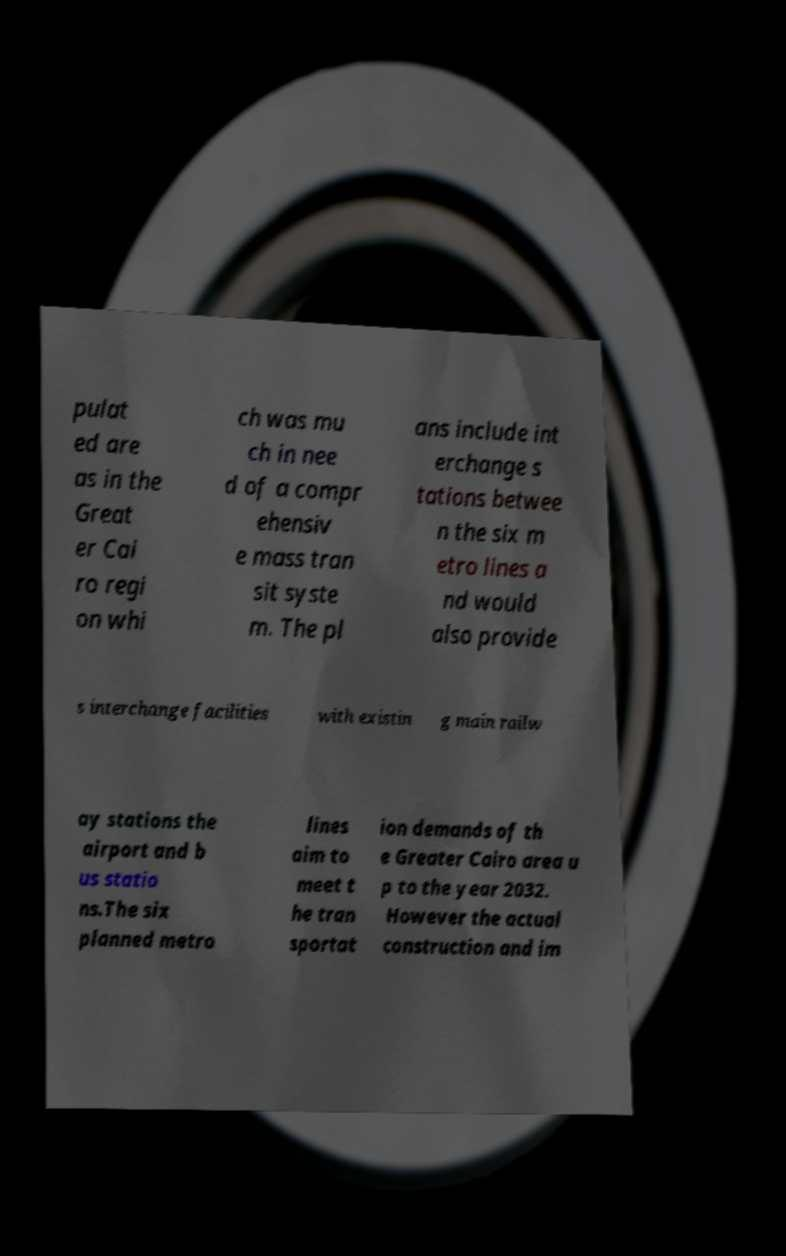Could you extract and type out the text from this image? pulat ed are as in the Great er Cai ro regi on whi ch was mu ch in nee d of a compr ehensiv e mass tran sit syste m. The pl ans include int erchange s tations betwee n the six m etro lines a nd would also provide s interchange facilities with existin g main railw ay stations the airport and b us statio ns.The six planned metro lines aim to meet t he tran sportat ion demands of th e Greater Cairo area u p to the year 2032. However the actual construction and im 